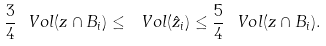Convert formula to latex. <formula><loc_0><loc_0><loc_500><loc_500>\frac { 3 } { 4 } \ V o l ( z \cap B _ { i } ) \leq \ V o l ( \hat { z } _ { i } ) \leq \frac { 5 } { 4 } \ V o l ( z \cap B _ { i } ) .</formula> 